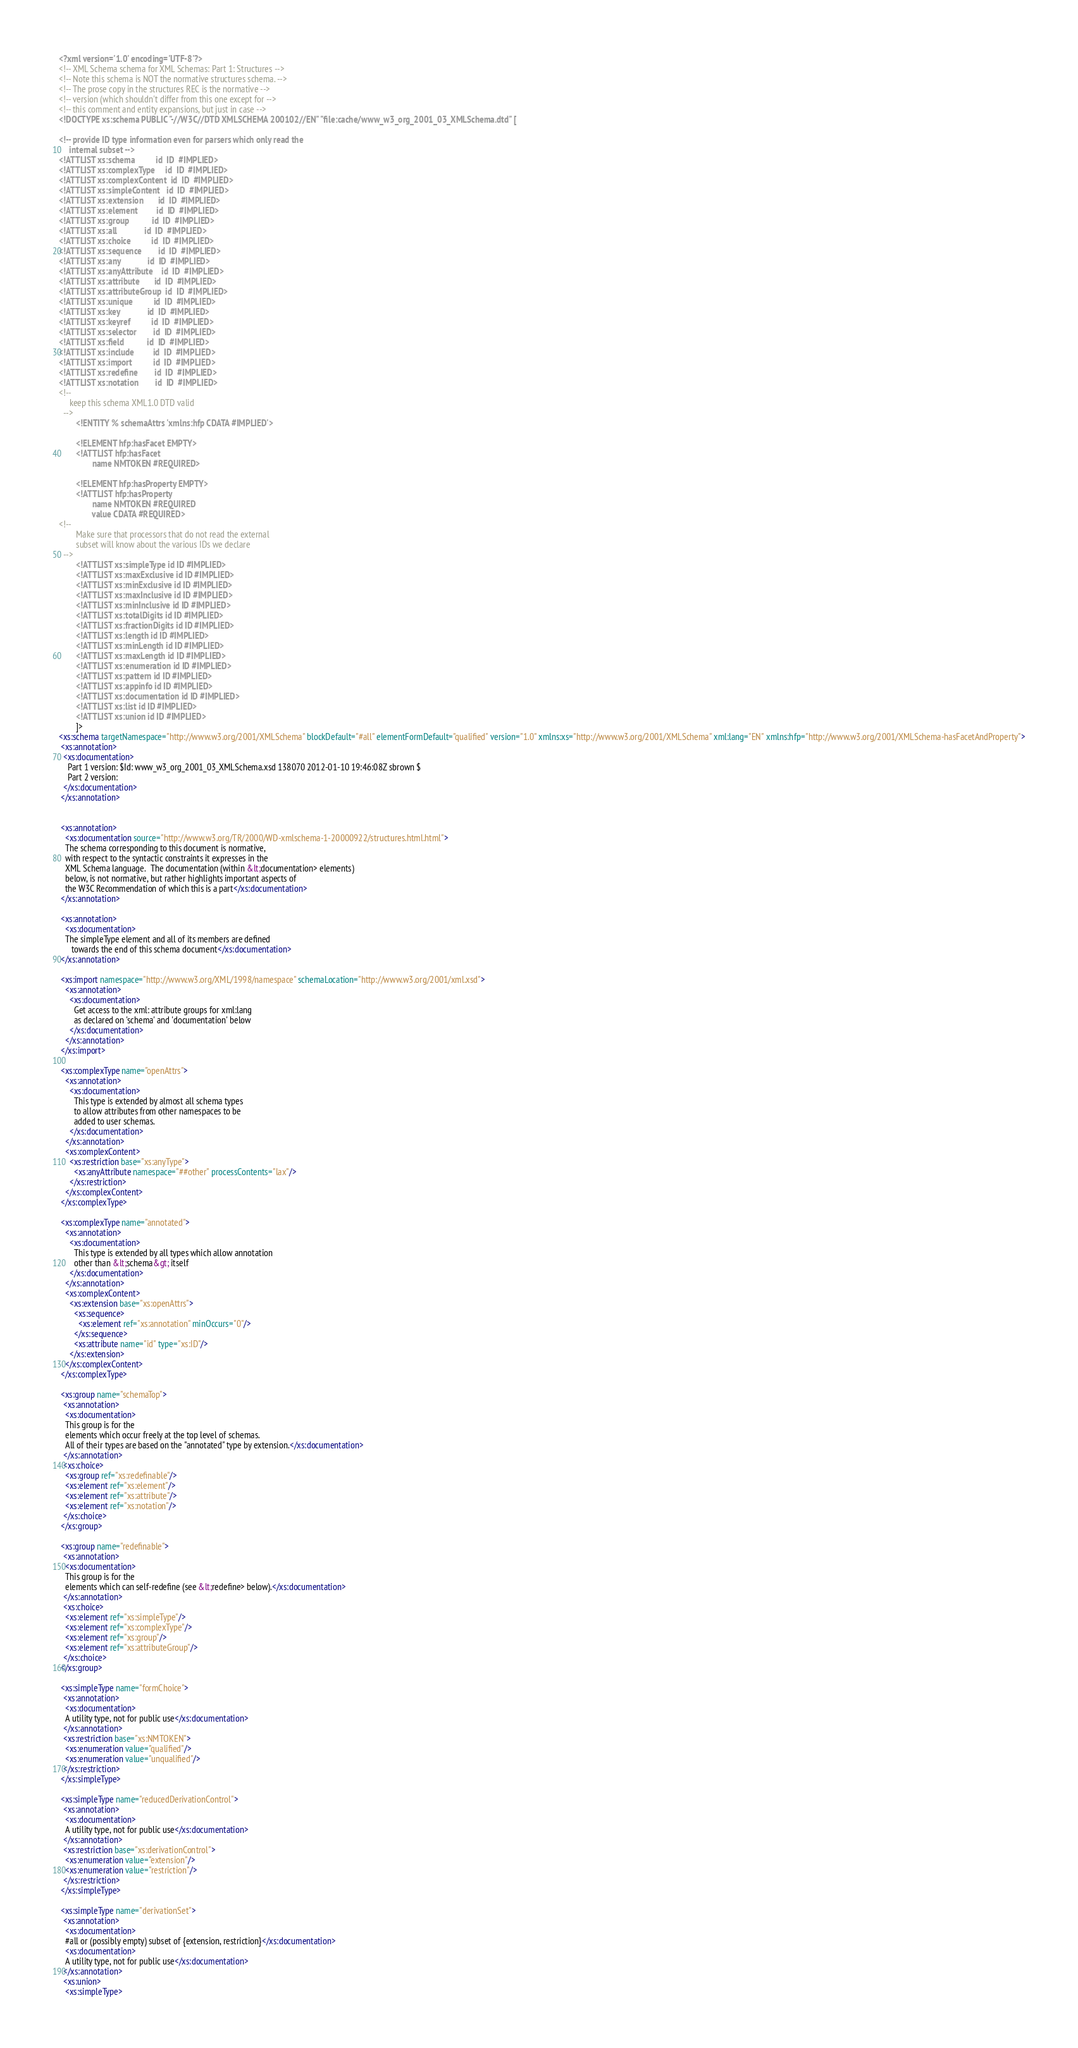<code> <loc_0><loc_0><loc_500><loc_500><_XML_><?xml version='1.0' encoding='UTF-8'?>
<!-- XML Schema schema for XML Schemas: Part 1: Structures -->
<!-- Note this schema is NOT the normative structures schema. -->
<!-- The prose copy in the structures REC is the normative -->
<!-- version (which shouldn't differ from this one except for -->
<!-- this comment and entity expansions, but just in case -->
<!DOCTYPE xs:schema PUBLIC "-//W3C//DTD XMLSCHEMA 200102//EN" "file:cache/www_w3_org_2001_03_XMLSchema.dtd" [

<!-- provide ID type information even for parsers which only read the
     internal subset -->
<!ATTLIST xs:schema          id  ID  #IMPLIED>
<!ATTLIST xs:complexType     id  ID  #IMPLIED>
<!ATTLIST xs:complexContent  id  ID  #IMPLIED>
<!ATTLIST xs:simpleContent   id  ID  #IMPLIED>
<!ATTLIST xs:extension       id  ID  #IMPLIED>
<!ATTLIST xs:element         id  ID  #IMPLIED>
<!ATTLIST xs:group           id  ID  #IMPLIED> 
<!ATTLIST xs:all             id  ID  #IMPLIED>
<!ATTLIST xs:choice          id  ID  #IMPLIED>
<!ATTLIST xs:sequence        id  ID  #IMPLIED>
<!ATTLIST xs:any             id  ID  #IMPLIED>
<!ATTLIST xs:anyAttribute    id  ID  #IMPLIED>
<!ATTLIST xs:attribute       id  ID  #IMPLIED>
<!ATTLIST xs:attributeGroup  id  ID  #IMPLIED>
<!ATTLIST xs:unique          id  ID  #IMPLIED>
<!ATTLIST xs:key             id  ID  #IMPLIED>
<!ATTLIST xs:keyref          id  ID  #IMPLIED>
<!ATTLIST xs:selector        id  ID  #IMPLIED>
<!ATTLIST xs:field           id  ID  #IMPLIED>
<!ATTLIST xs:include         id  ID  #IMPLIED>
<!ATTLIST xs:import          id  ID  #IMPLIED>
<!ATTLIST xs:redefine        id  ID  #IMPLIED>
<!ATTLIST xs:notation        id  ID  #IMPLIED>
<!--
     keep this schema XML1.0 DTD valid
  -->
        <!ENTITY % schemaAttrs 'xmlns:hfp CDATA #IMPLIED'>

        <!ELEMENT hfp:hasFacet EMPTY>
        <!ATTLIST hfp:hasFacet
                name NMTOKEN #REQUIRED>
                
        <!ELEMENT hfp:hasProperty EMPTY>
        <!ATTLIST hfp:hasProperty
                name NMTOKEN #REQUIRED
                value CDATA #REQUIRED>
<!--
        Make sure that processors that do not read the external
        subset will know about the various IDs we declare
  -->
        <!ATTLIST xs:simpleType id ID #IMPLIED>
        <!ATTLIST xs:maxExclusive id ID #IMPLIED>
        <!ATTLIST xs:minExclusive id ID #IMPLIED>
        <!ATTLIST xs:maxInclusive id ID #IMPLIED>
        <!ATTLIST xs:minInclusive id ID #IMPLIED>
        <!ATTLIST xs:totalDigits id ID #IMPLIED>
        <!ATTLIST xs:fractionDigits id ID #IMPLIED>
        <!ATTLIST xs:length id ID #IMPLIED>
        <!ATTLIST xs:minLength id ID #IMPLIED>
        <!ATTLIST xs:maxLength id ID #IMPLIED>
        <!ATTLIST xs:enumeration id ID #IMPLIED>
        <!ATTLIST xs:pattern id ID #IMPLIED>
        <!ATTLIST xs:appinfo id ID #IMPLIED>
        <!ATTLIST xs:documentation id ID #IMPLIED>
        <!ATTLIST xs:list id ID #IMPLIED>
        <!ATTLIST xs:union id ID #IMPLIED>
        ]>
<xs:schema targetNamespace="http://www.w3.org/2001/XMLSchema" blockDefault="#all" elementFormDefault="qualified" version="1.0" xmlns:xs="http://www.w3.org/2001/XMLSchema" xml:lang="EN" xmlns:hfp="http://www.w3.org/2001/XMLSchema-hasFacetAndProperty">
 <xs:annotation>
  <xs:documentation>
    Part 1 version: $Id: www_w3_org_2001_03_XMLSchema.xsd 138070 2012-01-10 19:46:08Z sbrown $
    Part 2 version: 
  </xs:documentation>
 </xs:annotation>


 <xs:annotation>
   <xs:documentation source="http://www.w3.org/TR/2000/WD-xmlschema-1-20000922/structures.html.html">
   The schema corresponding to this document is normative,
   with respect to the syntactic constraints it expresses in the
   XML Schema language.  The documentation (within &lt;documentation> elements)
   below, is not normative, but rather highlights important aspects of
   the W3C Recommendation of which this is a part</xs:documentation>
 </xs:annotation>

 <xs:annotation>
   <xs:documentation>
   The simpleType element and all of its members are defined
      towards the end of this schema document</xs:documentation>
 </xs:annotation>

 <xs:import namespace="http://www.w3.org/XML/1998/namespace" schemaLocation="http://www.w3.org/2001/xml.xsd">
   <xs:annotation>
     <xs:documentation>
       Get access to the xml: attribute groups for xml:lang
       as declared on 'schema' and 'documentation' below
     </xs:documentation>
   </xs:annotation>
 </xs:import>

 <xs:complexType name="openAttrs">
   <xs:annotation>
     <xs:documentation>
       This type is extended by almost all schema types
       to allow attributes from other namespaces to be
       added to user schemas.
     </xs:documentation>
   </xs:annotation>
   <xs:complexContent>
     <xs:restriction base="xs:anyType">
       <xs:anyAttribute namespace="##other" processContents="lax"/>
     </xs:restriction>
   </xs:complexContent>
 </xs:complexType>

 <xs:complexType name="annotated">
   <xs:annotation>
     <xs:documentation>
       This type is extended by all types which allow annotation
       other than &lt;schema&gt; itself
     </xs:documentation>
   </xs:annotation>
   <xs:complexContent>
     <xs:extension base="xs:openAttrs">
       <xs:sequence>
         <xs:element ref="xs:annotation" minOccurs="0"/>
       </xs:sequence>
       <xs:attribute name="id" type="xs:ID"/>
     </xs:extension>
   </xs:complexContent>
 </xs:complexType>

 <xs:group name="schemaTop">
  <xs:annotation>
   <xs:documentation>
   This group is for the
   elements which occur freely at the top level of schemas.
   All of their types are based on the "annotated" type by extension.</xs:documentation>
  </xs:annotation>
  <xs:choice>
   <xs:group ref="xs:redefinable"/>
   <xs:element ref="xs:element"/>
   <xs:element ref="xs:attribute"/>
   <xs:element ref="xs:notation"/>
  </xs:choice>
 </xs:group>
 
 <xs:group name="redefinable">
  <xs:annotation>
   <xs:documentation>
   This group is for the
   elements which can self-redefine (see &lt;redefine> below).</xs:documentation>
  </xs:annotation>
  <xs:choice>
   <xs:element ref="xs:simpleType"/>
   <xs:element ref="xs:complexType"/>
   <xs:element ref="xs:group"/>
   <xs:element ref="xs:attributeGroup"/>
  </xs:choice>
 </xs:group>

 <xs:simpleType name="formChoice">
  <xs:annotation>
   <xs:documentation>
   A utility type, not for public use</xs:documentation>
  </xs:annotation>
  <xs:restriction base="xs:NMTOKEN">
   <xs:enumeration value="qualified"/>
   <xs:enumeration value="unqualified"/>
  </xs:restriction>
 </xs:simpleType>

 <xs:simpleType name="reducedDerivationControl">
  <xs:annotation>
   <xs:documentation>
   A utility type, not for public use</xs:documentation>
  </xs:annotation>
  <xs:restriction base="xs:derivationControl">
   <xs:enumeration value="extension"/>
   <xs:enumeration value="restriction"/>
  </xs:restriction>
 </xs:simpleType>

 <xs:simpleType name="derivationSet">
  <xs:annotation>
   <xs:documentation>
   #all or (possibly empty) subset of {extension, restriction}</xs:documentation>
   <xs:documentation>
   A utility type, not for public use</xs:documentation>
  </xs:annotation>
  <xs:union>
   <xs:simpleType>    </code> 